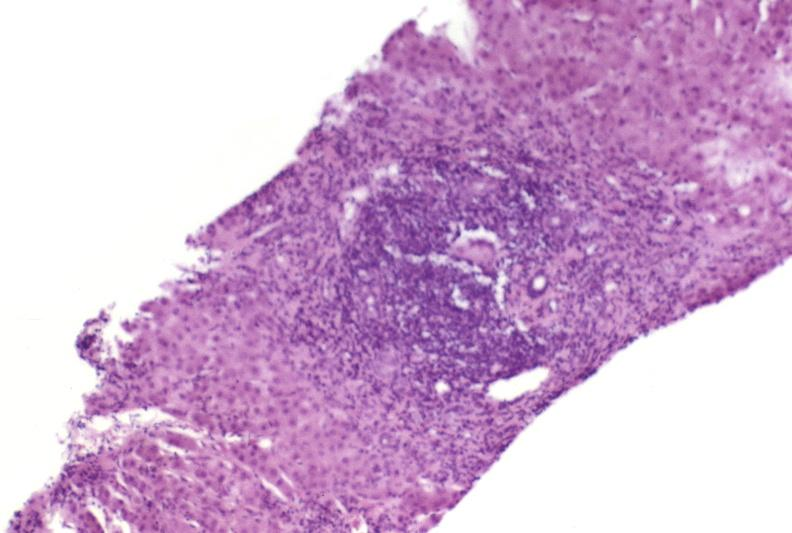does this image show autoimmune hepatitis?
Answer the question using a single word or phrase. Yes 